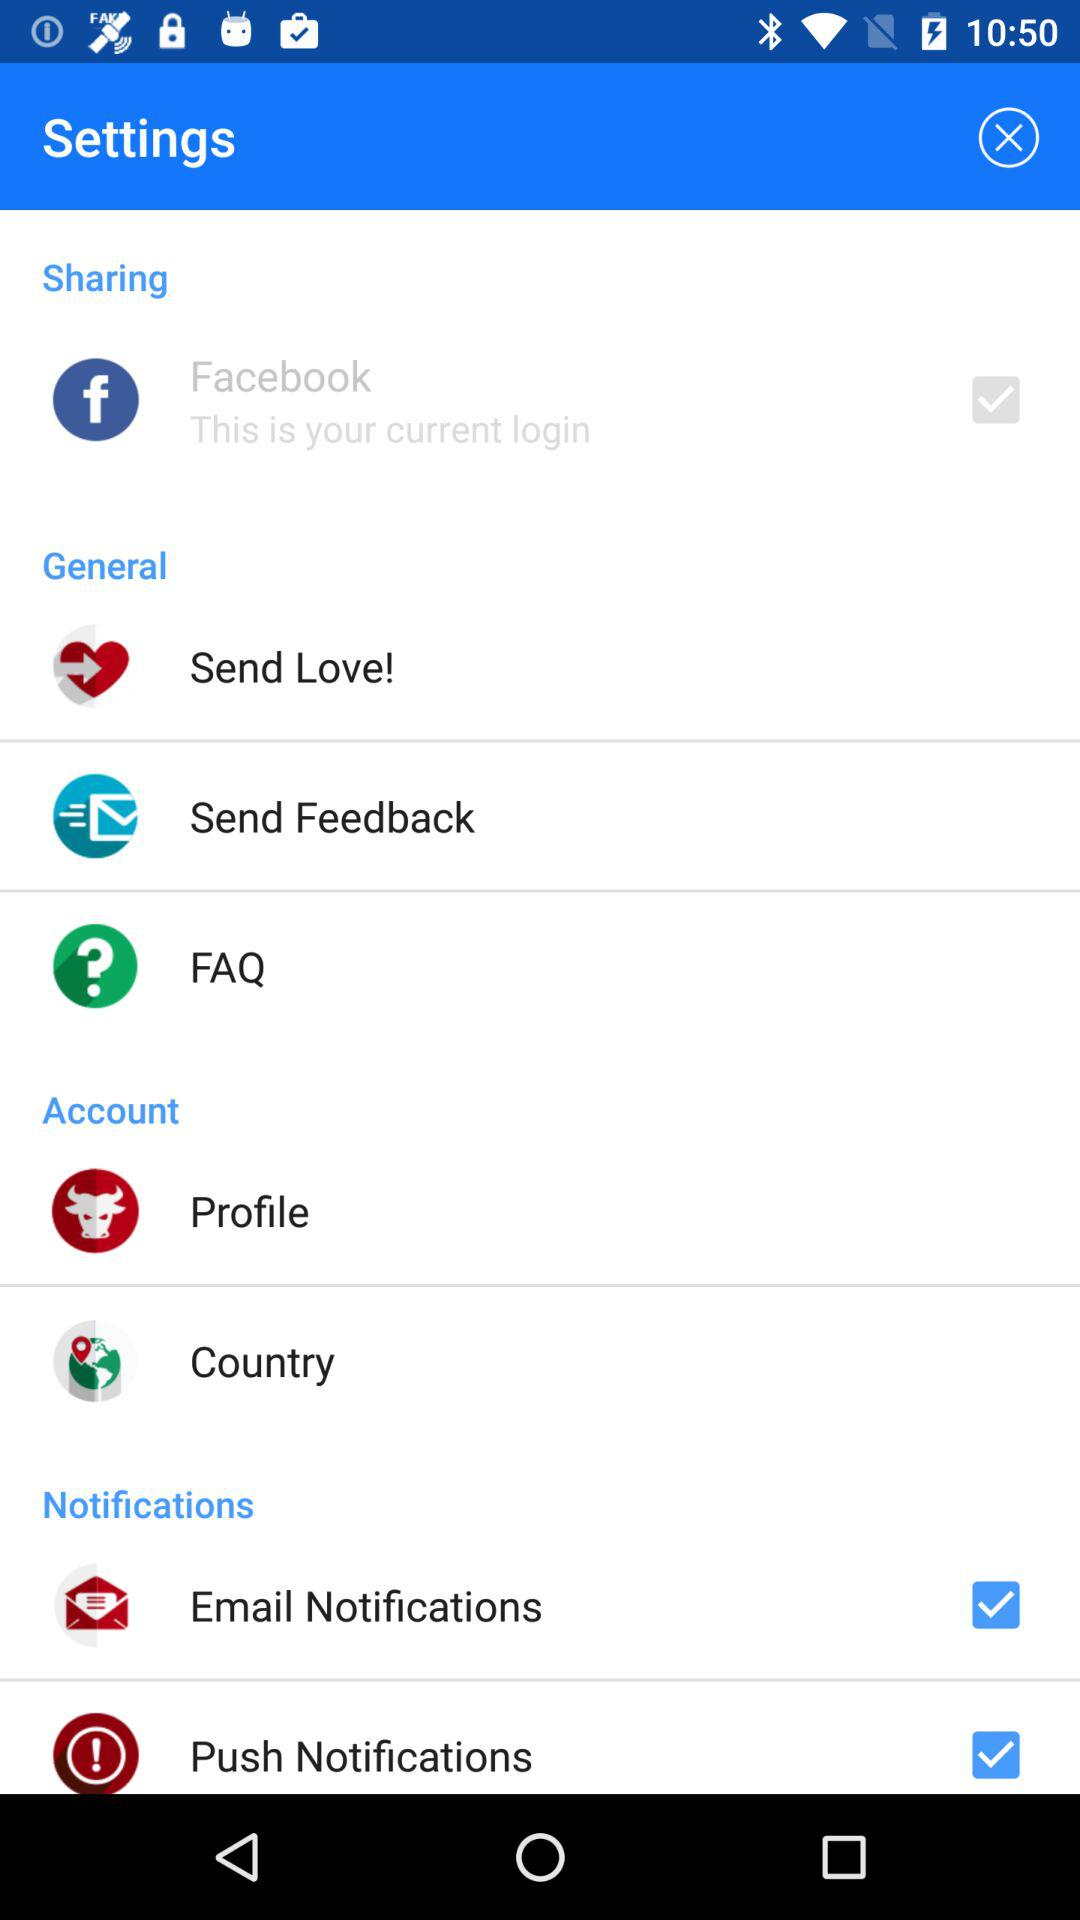What app is your current login? The current login app is "Facebook". 